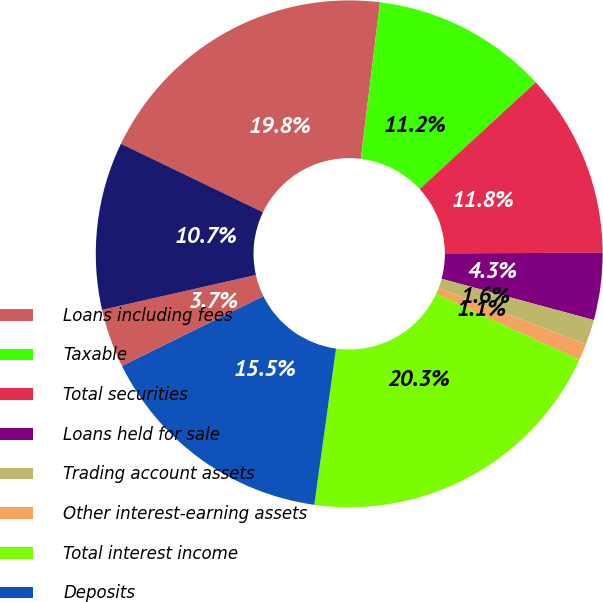Convert chart to OTSL. <chart><loc_0><loc_0><loc_500><loc_500><pie_chart><fcel>Loans including fees<fcel>Taxable<fcel>Total securities<fcel>Loans held for sale<fcel>Trading account assets<fcel>Other interest-earning assets<fcel>Total interest income<fcel>Deposits<fcel>Short-term borrowings<fcel>Long-term borrowings<nl><fcel>19.79%<fcel>11.23%<fcel>11.76%<fcel>4.28%<fcel>1.6%<fcel>1.07%<fcel>20.32%<fcel>15.51%<fcel>3.74%<fcel>10.7%<nl></chart> 